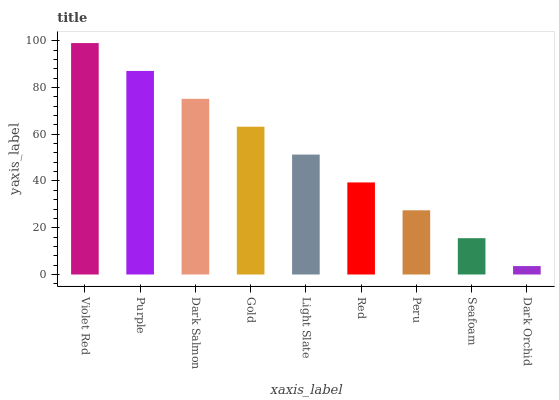Is Dark Orchid the minimum?
Answer yes or no. Yes. Is Violet Red the maximum?
Answer yes or no. Yes. Is Purple the minimum?
Answer yes or no. No. Is Purple the maximum?
Answer yes or no. No. Is Violet Red greater than Purple?
Answer yes or no. Yes. Is Purple less than Violet Red?
Answer yes or no. Yes. Is Purple greater than Violet Red?
Answer yes or no. No. Is Violet Red less than Purple?
Answer yes or no. No. Is Light Slate the high median?
Answer yes or no. Yes. Is Light Slate the low median?
Answer yes or no. Yes. Is Purple the high median?
Answer yes or no. No. Is Seafoam the low median?
Answer yes or no. No. 